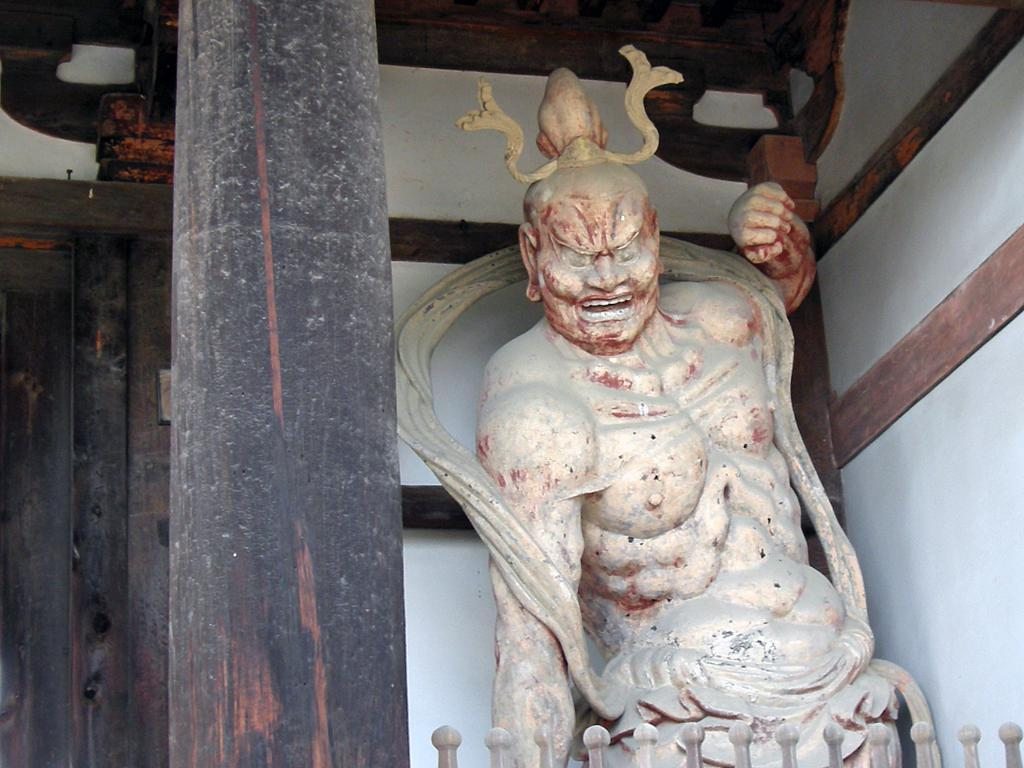What is the main subject in the image? There is a statue of a person in the image. What can be seen on the left side of the image? There is a door on the left side of the image. What is beside the door? There is a wooden pillar beside the door. How many goldfish are swimming near the statue in the image? There are no goldfish present in the image. 